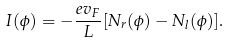Convert formula to latex. <formula><loc_0><loc_0><loc_500><loc_500>I ( \phi ) = - \frac { e v _ { F } } { L } [ N _ { r } ( \phi ) - N _ { l } ( \phi ) ] .</formula> 